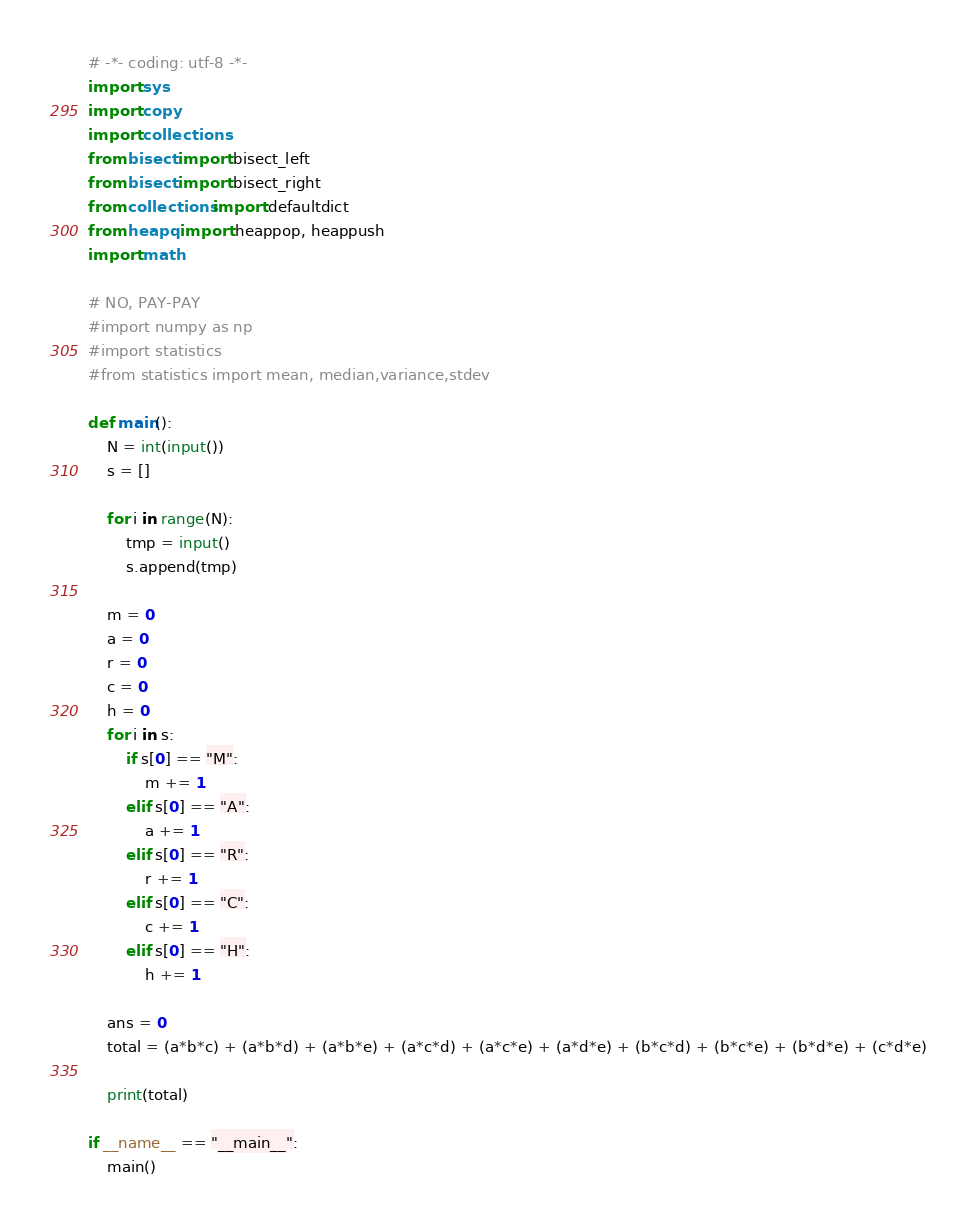Convert code to text. <code><loc_0><loc_0><loc_500><loc_500><_Python_># -*- coding: utf-8 -*-
import sys
import copy
import collections
from bisect import bisect_left
from bisect import bisect_right
from collections import defaultdict
from heapq import heappop, heappush
import math

# NO, PAY-PAY
#import numpy as np
#import statistics
#from statistics import mean, median,variance,stdev
 
def main():
    N = int(input())
    s = []
    
    for i in range(N):
        tmp = input()
        s.append(tmp)
        
    m = 0
    a = 0
    r = 0
    c = 0
    h = 0
    for i in s:
        if s[0] == "M":
            m += 1
        elif s[0] == "A":
            a += 1
        elif s[0] == "R":
            r += 1
        elif s[0] == "C":
            c += 1
        elif s[0] == "H":
            h += 1
            
    ans = 0
    total = (a*b*c) + (a*b*d) + (a*b*e) + (a*c*d) + (a*c*e) + (a*d*e) + (b*c*d) + (b*c*e) + (b*d*e) + (c*d*e)
            
    print(total)
	
if __name__ == "__main__":
	main()
</code> 